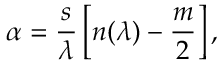Convert formula to latex. <formula><loc_0><loc_0><loc_500><loc_500>\alpha = \frac { s } { \lambda } \left [ n ( \lambda ) - \frac { m } { 2 } \right ] ,</formula> 